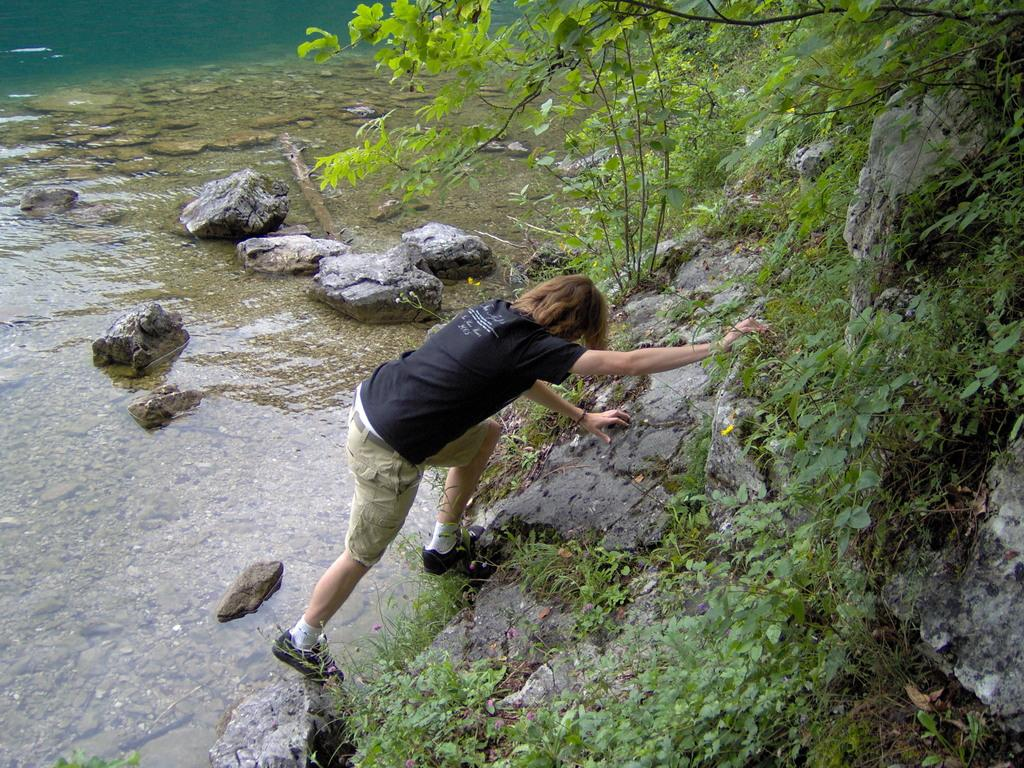Who or what is present in the image? There is a person in the image. What is the person wearing? The person is wearing a black T-shirt. What can be seen at the bottom of the image? There is water at the bottom of the image. What is located to the right of the image? There are rocks along with plants to the right of the image. What type of humor does the person in the image display? There is no indication of humor in the image; it simply shows a person wearing a black T-shirt in a setting with water, rocks, and plants. 